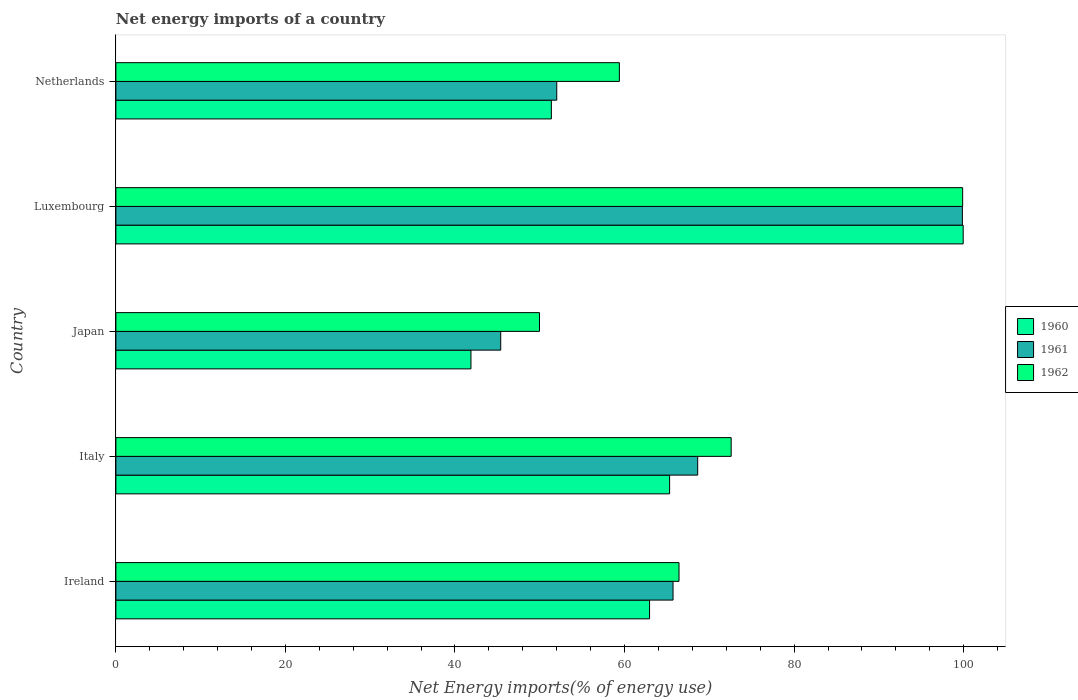Are the number of bars on each tick of the Y-axis equal?
Give a very brief answer. Yes. How many bars are there on the 1st tick from the top?
Your response must be concise. 3. What is the label of the 3rd group of bars from the top?
Your response must be concise. Japan. What is the net energy imports in 1960 in Japan?
Your response must be concise. 41.88. Across all countries, what is the maximum net energy imports in 1962?
Make the answer very short. 99.88. Across all countries, what is the minimum net energy imports in 1960?
Your response must be concise. 41.88. In which country was the net energy imports in 1960 maximum?
Provide a succinct answer. Luxembourg. What is the total net energy imports in 1961 in the graph?
Offer a very short reply. 331.6. What is the difference between the net energy imports in 1960 in Japan and that in Netherlands?
Offer a very short reply. -9.49. What is the difference between the net energy imports in 1960 in Netherlands and the net energy imports in 1961 in Japan?
Give a very brief answer. 5.97. What is the average net energy imports in 1962 per country?
Your answer should be very brief. 69.65. What is the difference between the net energy imports in 1960 and net energy imports in 1961 in Ireland?
Your response must be concise. -2.77. In how many countries, is the net energy imports in 1960 greater than 84 %?
Offer a very short reply. 1. What is the ratio of the net energy imports in 1962 in Luxembourg to that in Netherlands?
Keep it short and to the point. 1.68. Is the net energy imports in 1961 in Italy less than that in Japan?
Your response must be concise. No. Is the difference between the net energy imports in 1960 in Ireland and Luxembourg greater than the difference between the net energy imports in 1961 in Ireland and Luxembourg?
Your answer should be very brief. No. What is the difference between the highest and the second highest net energy imports in 1961?
Provide a succinct answer. 31.22. What is the difference between the highest and the lowest net energy imports in 1961?
Your response must be concise. 54.46. Is the sum of the net energy imports in 1961 in Italy and Luxembourg greater than the maximum net energy imports in 1962 across all countries?
Your response must be concise. Yes. What does the 3rd bar from the top in Luxembourg represents?
Your answer should be very brief. 1960. What does the 2nd bar from the bottom in Japan represents?
Ensure brevity in your answer.  1961. Are all the bars in the graph horizontal?
Your response must be concise. Yes. How many countries are there in the graph?
Provide a succinct answer. 5. Are the values on the major ticks of X-axis written in scientific E-notation?
Provide a short and direct response. No. Does the graph contain grids?
Your answer should be compact. No. What is the title of the graph?
Make the answer very short. Net energy imports of a country. Does "1969" appear as one of the legend labels in the graph?
Make the answer very short. No. What is the label or title of the X-axis?
Provide a succinct answer. Net Energy imports(% of energy use). What is the label or title of the Y-axis?
Give a very brief answer. Country. What is the Net Energy imports(% of energy use) of 1960 in Ireland?
Your answer should be very brief. 62.95. What is the Net Energy imports(% of energy use) of 1961 in Ireland?
Keep it short and to the point. 65.72. What is the Net Energy imports(% of energy use) in 1962 in Ireland?
Your answer should be very brief. 66.43. What is the Net Energy imports(% of energy use) of 1960 in Italy?
Offer a very short reply. 65.32. What is the Net Energy imports(% of energy use) of 1961 in Italy?
Ensure brevity in your answer.  68.63. What is the Net Energy imports(% of energy use) in 1962 in Italy?
Offer a terse response. 72.58. What is the Net Energy imports(% of energy use) of 1960 in Japan?
Your answer should be very brief. 41.88. What is the Net Energy imports(% of energy use) of 1961 in Japan?
Offer a very short reply. 45.39. What is the Net Energy imports(% of energy use) of 1962 in Japan?
Provide a short and direct response. 49.97. What is the Net Energy imports(% of energy use) of 1960 in Luxembourg?
Ensure brevity in your answer.  99.95. What is the Net Energy imports(% of energy use) in 1961 in Luxembourg?
Your answer should be compact. 99.85. What is the Net Energy imports(% of energy use) in 1962 in Luxembourg?
Your response must be concise. 99.88. What is the Net Energy imports(% of energy use) of 1960 in Netherlands?
Make the answer very short. 51.37. What is the Net Energy imports(% of energy use) of 1961 in Netherlands?
Offer a terse response. 52. What is the Net Energy imports(% of energy use) in 1962 in Netherlands?
Make the answer very short. 59.39. Across all countries, what is the maximum Net Energy imports(% of energy use) in 1960?
Give a very brief answer. 99.95. Across all countries, what is the maximum Net Energy imports(% of energy use) of 1961?
Keep it short and to the point. 99.85. Across all countries, what is the maximum Net Energy imports(% of energy use) in 1962?
Offer a very short reply. 99.88. Across all countries, what is the minimum Net Energy imports(% of energy use) in 1960?
Your answer should be very brief. 41.88. Across all countries, what is the minimum Net Energy imports(% of energy use) in 1961?
Ensure brevity in your answer.  45.39. Across all countries, what is the minimum Net Energy imports(% of energy use) in 1962?
Your answer should be compact. 49.97. What is the total Net Energy imports(% of energy use) of 1960 in the graph?
Give a very brief answer. 321.47. What is the total Net Energy imports(% of energy use) in 1961 in the graph?
Provide a succinct answer. 331.6. What is the total Net Energy imports(% of energy use) of 1962 in the graph?
Offer a very short reply. 348.25. What is the difference between the Net Energy imports(% of energy use) in 1960 in Ireland and that in Italy?
Your response must be concise. -2.36. What is the difference between the Net Energy imports(% of energy use) in 1961 in Ireland and that in Italy?
Your answer should be compact. -2.91. What is the difference between the Net Energy imports(% of energy use) in 1962 in Ireland and that in Italy?
Give a very brief answer. -6.15. What is the difference between the Net Energy imports(% of energy use) of 1960 in Ireland and that in Japan?
Your answer should be very brief. 21.07. What is the difference between the Net Energy imports(% of energy use) of 1961 in Ireland and that in Japan?
Your answer should be very brief. 20.33. What is the difference between the Net Energy imports(% of energy use) in 1962 in Ireland and that in Japan?
Provide a succinct answer. 16.46. What is the difference between the Net Energy imports(% of energy use) of 1960 in Ireland and that in Luxembourg?
Provide a succinct answer. -37. What is the difference between the Net Energy imports(% of energy use) of 1961 in Ireland and that in Luxembourg?
Provide a short and direct response. -34.13. What is the difference between the Net Energy imports(% of energy use) in 1962 in Ireland and that in Luxembourg?
Your answer should be compact. -33.46. What is the difference between the Net Energy imports(% of energy use) of 1960 in Ireland and that in Netherlands?
Provide a short and direct response. 11.58. What is the difference between the Net Energy imports(% of energy use) in 1961 in Ireland and that in Netherlands?
Ensure brevity in your answer.  13.72. What is the difference between the Net Energy imports(% of energy use) in 1962 in Ireland and that in Netherlands?
Give a very brief answer. 7.03. What is the difference between the Net Energy imports(% of energy use) in 1960 in Italy and that in Japan?
Keep it short and to the point. 23.43. What is the difference between the Net Energy imports(% of energy use) in 1961 in Italy and that in Japan?
Ensure brevity in your answer.  23.24. What is the difference between the Net Energy imports(% of energy use) in 1962 in Italy and that in Japan?
Your response must be concise. 22.61. What is the difference between the Net Energy imports(% of energy use) of 1960 in Italy and that in Luxembourg?
Keep it short and to the point. -34.63. What is the difference between the Net Energy imports(% of energy use) of 1961 in Italy and that in Luxembourg?
Ensure brevity in your answer.  -31.22. What is the difference between the Net Energy imports(% of energy use) of 1962 in Italy and that in Luxembourg?
Give a very brief answer. -27.31. What is the difference between the Net Energy imports(% of energy use) in 1960 in Italy and that in Netherlands?
Offer a terse response. 13.95. What is the difference between the Net Energy imports(% of energy use) of 1961 in Italy and that in Netherlands?
Your response must be concise. 16.63. What is the difference between the Net Energy imports(% of energy use) in 1962 in Italy and that in Netherlands?
Your answer should be very brief. 13.19. What is the difference between the Net Energy imports(% of energy use) of 1960 in Japan and that in Luxembourg?
Offer a very short reply. -58.07. What is the difference between the Net Energy imports(% of energy use) of 1961 in Japan and that in Luxembourg?
Provide a succinct answer. -54.46. What is the difference between the Net Energy imports(% of energy use) of 1962 in Japan and that in Luxembourg?
Give a very brief answer. -49.92. What is the difference between the Net Energy imports(% of energy use) of 1960 in Japan and that in Netherlands?
Make the answer very short. -9.49. What is the difference between the Net Energy imports(% of energy use) of 1961 in Japan and that in Netherlands?
Ensure brevity in your answer.  -6.61. What is the difference between the Net Energy imports(% of energy use) in 1962 in Japan and that in Netherlands?
Your answer should be very brief. -9.42. What is the difference between the Net Energy imports(% of energy use) of 1960 in Luxembourg and that in Netherlands?
Provide a short and direct response. 48.58. What is the difference between the Net Energy imports(% of energy use) of 1961 in Luxembourg and that in Netherlands?
Make the answer very short. 47.85. What is the difference between the Net Energy imports(% of energy use) in 1962 in Luxembourg and that in Netherlands?
Provide a short and direct response. 40.49. What is the difference between the Net Energy imports(% of energy use) of 1960 in Ireland and the Net Energy imports(% of energy use) of 1961 in Italy?
Offer a terse response. -5.68. What is the difference between the Net Energy imports(% of energy use) in 1960 in Ireland and the Net Energy imports(% of energy use) in 1962 in Italy?
Ensure brevity in your answer.  -9.63. What is the difference between the Net Energy imports(% of energy use) of 1961 in Ireland and the Net Energy imports(% of energy use) of 1962 in Italy?
Make the answer very short. -6.86. What is the difference between the Net Energy imports(% of energy use) in 1960 in Ireland and the Net Energy imports(% of energy use) in 1961 in Japan?
Offer a terse response. 17.56. What is the difference between the Net Energy imports(% of energy use) in 1960 in Ireland and the Net Energy imports(% of energy use) in 1962 in Japan?
Your response must be concise. 12.98. What is the difference between the Net Energy imports(% of energy use) in 1961 in Ireland and the Net Energy imports(% of energy use) in 1962 in Japan?
Your answer should be compact. 15.75. What is the difference between the Net Energy imports(% of energy use) of 1960 in Ireland and the Net Energy imports(% of energy use) of 1961 in Luxembourg?
Offer a terse response. -36.9. What is the difference between the Net Energy imports(% of energy use) of 1960 in Ireland and the Net Energy imports(% of energy use) of 1962 in Luxembourg?
Your answer should be compact. -36.93. What is the difference between the Net Energy imports(% of energy use) in 1961 in Ireland and the Net Energy imports(% of energy use) in 1962 in Luxembourg?
Provide a short and direct response. -34.16. What is the difference between the Net Energy imports(% of energy use) in 1960 in Ireland and the Net Energy imports(% of energy use) in 1961 in Netherlands?
Provide a succinct answer. 10.95. What is the difference between the Net Energy imports(% of energy use) of 1960 in Ireland and the Net Energy imports(% of energy use) of 1962 in Netherlands?
Your answer should be compact. 3.56. What is the difference between the Net Energy imports(% of energy use) of 1961 in Ireland and the Net Energy imports(% of energy use) of 1962 in Netherlands?
Your response must be concise. 6.33. What is the difference between the Net Energy imports(% of energy use) of 1960 in Italy and the Net Energy imports(% of energy use) of 1961 in Japan?
Provide a short and direct response. 19.92. What is the difference between the Net Energy imports(% of energy use) in 1960 in Italy and the Net Energy imports(% of energy use) in 1962 in Japan?
Your answer should be very brief. 15.35. What is the difference between the Net Energy imports(% of energy use) of 1961 in Italy and the Net Energy imports(% of energy use) of 1962 in Japan?
Your answer should be very brief. 18.66. What is the difference between the Net Energy imports(% of energy use) of 1960 in Italy and the Net Energy imports(% of energy use) of 1961 in Luxembourg?
Make the answer very short. -34.54. What is the difference between the Net Energy imports(% of energy use) of 1960 in Italy and the Net Energy imports(% of energy use) of 1962 in Luxembourg?
Give a very brief answer. -34.57. What is the difference between the Net Energy imports(% of energy use) in 1961 in Italy and the Net Energy imports(% of energy use) in 1962 in Luxembourg?
Your answer should be very brief. -31.25. What is the difference between the Net Energy imports(% of energy use) of 1960 in Italy and the Net Energy imports(% of energy use) of 1961 in Netherlands?
Keep it short and to the point. 13.31. What is the difference between the Net Energy imports(% of energy use) in 1960 in Italy and the Net Energy imports(% of energy use) in 1962 in Netherlands?
Give a very brief answer. 5.93. What is the difference between the Net Energy imports(% of energy use) in 1961 in Italy and the Net Energy imports(% of energy use) in 1962 in Netherlands?
Provide a succinct answer. 9.24. What is the difference between the Net Energy imports(% of energy use) in 1960 in Japan and the Net Energy imports(% of energy use) in 1961 in Luxembourg?
Offer a terse response. -57.97. What is the difference between the Net Energy imports(% of energy use) in 1960 in Japan and the Net Energy imports(% of energy use) in 1962 in Luxembourg?
Give a very brief answer. -58. What is the difference between the Net Energy imports(% of energy use) of 1961 in Japan and the Net Energy imports(% of energy use) of 1962 in Luxembourg?
Keep it short and to the point. -54.49. What is the difference between the Net Energy imports(% of energy use) in 1960 in Japan and the Net Energy imports(% of energy use) in 1961 in Netherlands?
Your answer should be very brief. -10.12. What is the difference between the Net Energy imports(% of energy use) of 1960 in Japan and the Net Energy imports(% of energy use) of 1962 in Netherlands?
Your answer should be very brief. -17.51. What is the difference between the Net Energy imports(% of energy use) in 1961 in Japan and the Net Energy imports(% of energy use) in 1962 in Netherlands?
Your answer should be compact. -14. What is the difference between the Net Energy imports(% of energy use) in 1960 in Luxembourg and the Net Energy imports(% of energy use) in 1961 in Netherlands?
Your answer should be compact. 47.94. What is the difference between the Net Energy imports(% of energy use) in 1960 in Luxembourg and the Net Energy imports(% of energy use) in 1962 in Netherlands?
Make the answer very short. 40.56. What is the difference between the Net Energy imports(% of energy use) of 1961 in Luxembourg and the Net Energy imports(% of energy use) of 1962 in Netherlands?
Your answer should be very brief. 40.46. What is the average Net Energy imports(% of energy use) in 1960 per country?
Offer a terse response. 64.29. What is the average Net Energy imports(% of energy use) of 1961 per country?
Your answer should be very brief. 66.32. What is the average Net Energy imports(% of energy use) of 1962 per country?
Provide a succinct answer. 69.65. What is the difference between the Net Energy imports(% of energy use) of 1960 and Net Energy imports(% of energy use) of 1961 in Ireland?
Your response must be concise. -2.77. What is the difference between the Net Energy imports(% of energy use) in 1960 and Net Energy imports(% of energy use) in 1962 in Ireland?
Provide a short and direct response. -3.47. What is the difference between the Net Energy imports(% of energy use) in 1961 and Net Energy imports(% of energy use) in 1962 in Ireland?
Make the answer very short. -0.7. What is the difference between the Net Energy imports(% of energy use) of 1960 and Net Energy imports(% of energy use) of 1961 in Italy?
Provide a short and direct response. -3.31. What is the difference between the Net Energy imports(% of energy use) of 1960 and Net Energy imports(% of energy use) of 1962 in Italy?
Keep it short and to the point. -7.26. What is the difference between the Net Energy imports(% of energy use) of 1961 and Net Energy imports(% of energy use) of 1962 in Italy?
Your answer should be very brief. -3.95. What is the difference between the Net Energy imports(% of energy use) of 1960 and Net Energy imports(% of energy use) of 1961 in Japan?
Provide a succinct answer. -3.51. What is the difference between the Net Energy imports(% of energy use) of 1960 and Net Energy imports(% of energy use) of 1962 in Japan?
Offer a terse response. -8.09. What is the difference between the Net Energy imports(% of energy use) of 1961 and Net Energy imports(% of energy use) of 1962 in Japan?
Give a very brief answer. -4.57. What is the difference between the Net Energy imports(% of energy use) of 1960 and Net Energy imports(% of energy use) of 1961 in Luxembourg?
Provide a short and direct response. 0.09. What is the difference between the Net Energy imports(% of energy use) in 1960 and Net Energy imports(% of energy use) in 1962 in Luxembourg?
Offer a very short reply. 0.06. What is the difference between the Net Energy imports(% of energy use) in 1961 and Net Energy imports(% of energy use) in 1962 in Luxembourg?
Offer a terse response. -0.03. What is the difference between the Net Energy imports(% of energy use) of 1960 and Net Energy imports(% of energy use) of 1961 in Netherlands?
Provide a succinct answer. -0.64. What is the difference between the Net Energy imports(% of energy use) of 1960 and Net Energy imports(% of energy use) of 1962 in Netherlands?
Give a very brief answer. -8.02. What is the difference between the Net Energy imports(% of energy use) in 1961 and Net Energy imports(% of energy use) in 1962 in Netherlands?
Your response must be concise. -7.39. What is the ratio of the Net Energy imports(% of energy use) in 1960 in Ireland to that in Italy?
Your response must be concise. 0.96. What is the ratio of the Net Energy imports(% of energy use) of 1961 in Ireland to that in Italy?
Give a very brief answer. 0.96. What is the ratio of the Net Energy imports(% of energy use) in 1962 in Ireland to that in Italy?
Offer a terse response. 0.92. What is the ratio of the Net Energy imports(% of energy use) in 1960 in Ireland to that in Japan?
Your response must be concise. 1.5. What is the ratio of the Net Energy imports(% of energy use) of 1961 in Ireland to that in Japan?
Provide a short and direct response. 1.45. What is the ratio of the Net Energy imports(% of energy use) of 1962 in Ireland to that in Japan?
Your answer should be compact. 1.33. What is the ratio of the Net Energy imports(% of energy use) in 1960 in Ireland to that in Luxembourg?
Your answer should be compact. 0.63. What is the ratio of the Net Energy imports(% of energy use) in 1961 in Ireland to that in Luxembourg?
Offer a terse response. 0.66. What is the ratio of the Net Energy imports(% of energy use) of 1962 in Ireland to that in Luxembourg?
Keep it short and to the point. 0.67. What is the ratio of the Net Energy imports(% of energy use) of 1960 in Ireland to that in Netherlands?
Offer a very short reply. 1.23. What is the ratio of the Net Energy imports(% of energy use) of 1961 in Ireland to that in Netherlands?
Ensure brevity in your answer.  1.26. What is the ratio of the Net Energy imports(% of energy use) in 1962 in Ireland to that in Netherlands?
Provide a succinct answer. 1.12. What is the ratio of the Net Energy imports(% of energy use) of 1960 in Italy to that in Japan?
Give a very brief answer. 1.56. What is the ratio of the Net Energy imports(% of energy use) in 1961 in Italy to that in Japan?
Offer a very short reply. 1.51. What is the ratio of the Net Energy imports(% of energy use) of 1962 in Italy to that in Japan?
Your answer should be compact. 1.45. What is the ratio of the Net Energy imports(% of energy use) of 1960 in Italy to that in Luxembourg?
Provide a short and direct response. 0.65. What is the ratio of the Net Energy imports(% of energy use) of 1961 in Italy to that in Luxembourg?
Offer a terse response. 0.69. What is the ratio of the Net Energy imports(% of energy use) in 1962 in Italy to that in Luxembourg?
Offer a terse response. 0.73. What is the ratio of the Net Energy imports(% of energy use) in 1960 in Italy to that in Netherlands?
Your answer should be compact. 1.27. What is the ratio of the Net Energy imports(% of energy use) of 1961 in Italy to that in Netherlands?
Offer a very short reply. 1.32. What is the ratio of the Net Energy imports(% of energy use) of 1962 in Italy to that in Netherlands?
Offer a terse response. 1.22. What is the ratio of the Net Energy imports(% of energy use) of 1960 in Japan to that in Luxembourg?
Keep it short and to the point. 0.42. What is the ratio of the Net Energy imports(% of energy use) of 1961 in Japan to that in Luxembourg?
Your response must be concise. 0.45. What is the ratio of the Net Energy imports(% of energy use) in 1962 in Japan to that in Luxembourg?
Your response must be concise. 0.5. What is the ratio of the Net Energy imports(% of energy use) in 1960 in Japan to that in Netherlands?
Your answer should be compact. 0.82. What is the ratio of the Net Energy imports(% of energy use) in 1961 in Japan to that in Netherlands?
Ensure brevity in your answer.  0.87. What is the ratio of the Net Energy imports(% of energy use) in 1962 in Japan to that in Netherlands?
Provide a succinct answer. 0.84. What is the ratio of the Net Energy imports(% of energy use) of 1960 in Luxembourg to that in Netherlands?
Provide a short and direct response. 1.95. What is the ratio of the Net Energy imports(% of energy use) in 1961 in Luxembourg to that in Netherlands?
Your answer should be compact. 1.92. What is the ratio of the Net Energy imports(% of energy use) in 1962 in Luxembourg to that in Netherlands?
Your answer should be very brief. 1.68. What is the difference between the highest and the second highest Net Energy imports(% of energy use) in 1960?
Give a very brief answer. 34.63. What is the difference between the highest and the second highest Net Energy imports(% of energy use) of 1961?
Make the answer very short. 31.22. What is the difference between the highest and the second highest Net Energy imports(% of energy use) in 1962?
Provide a succinct answer. 27.31. What is the difference between the highest and the lowest Net Energy imports(% of energy use) of 1960?
Ensure brevity in your answer.  58.07. What is the difference between the highest and the lowest Net Energy imports(% of energy use) in 1961?
Give a very brief answer. 54.46. What is the difference between the highest and the lowest Net Energy imports(% of energy use) in 1962?
Provide a short and direct response. 49.92. 